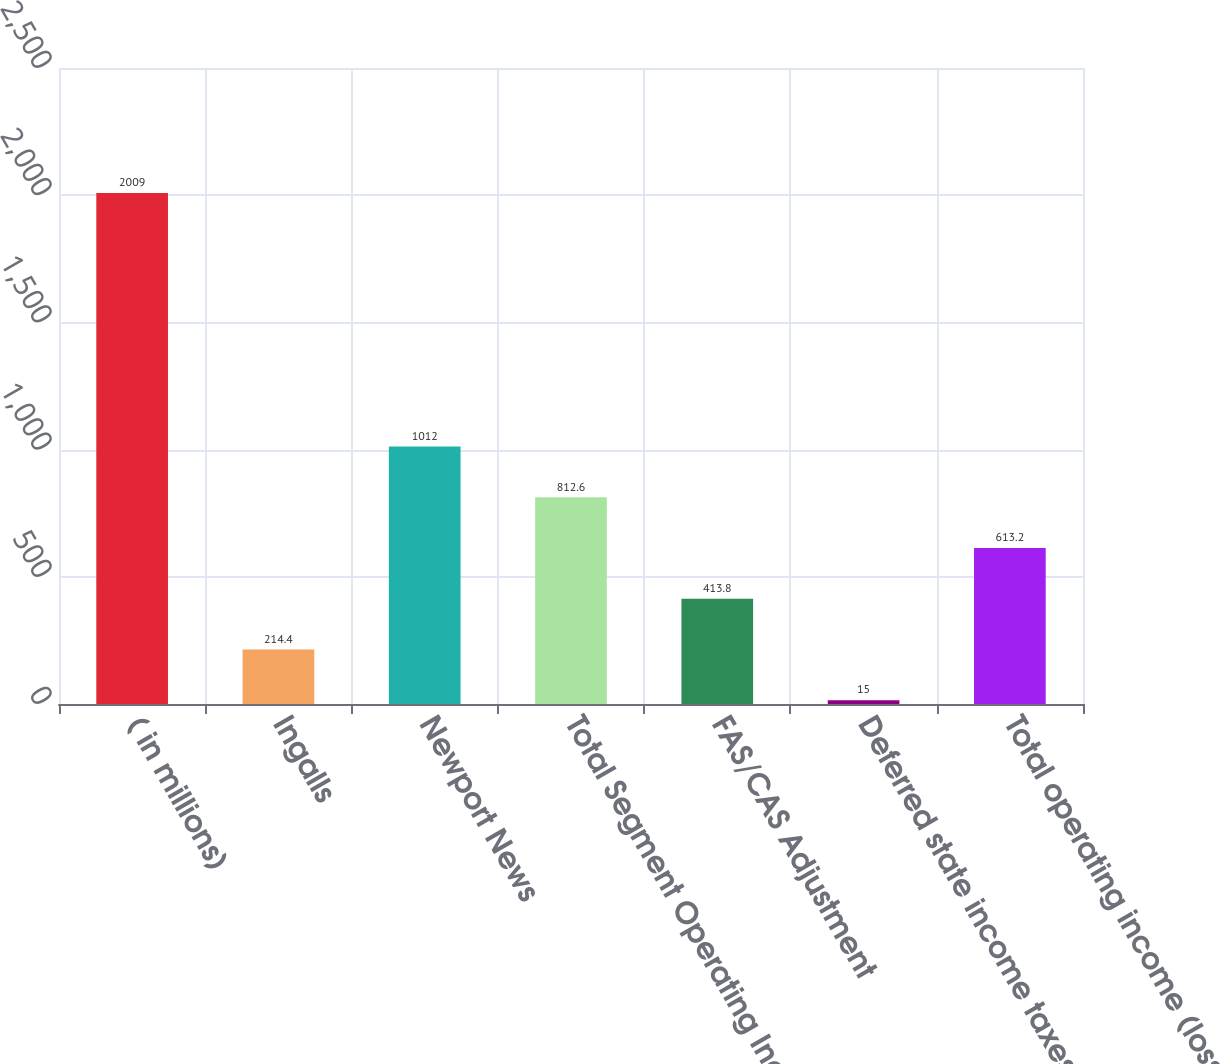<chart> <loc_0><loc_0><loc_500><loc_500><bar_chart><fcel>( in millions)<fcel>Ingalls<fcel>Newport News<fcel>Total Segment Operating Income<fcel>FAS/CAS Adjustment<fcel>Deferred state income taxes<fcel>Total operating income (loss)<nl><fcel>2009<fcel>214.4<fcel>1012<fcel>812.6<fcel>413.8<fcel>15<fcel>613.2<nl></chart> 